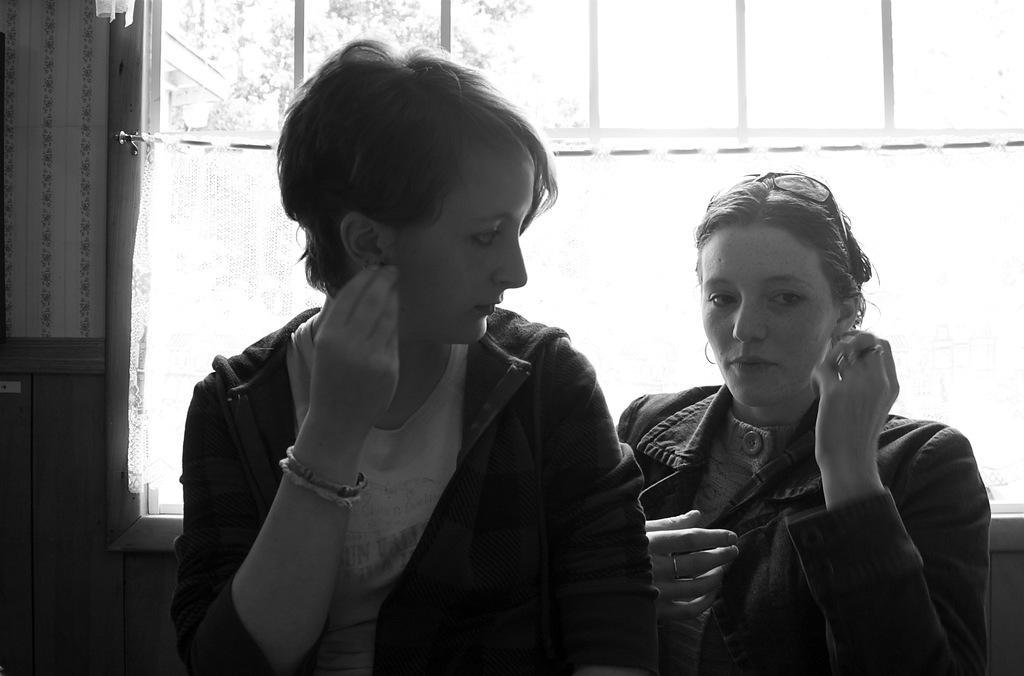Could you give a brief overview of what you see in this image? These two people wore jackets. This woman is looking at another woman. Background there is a window.  